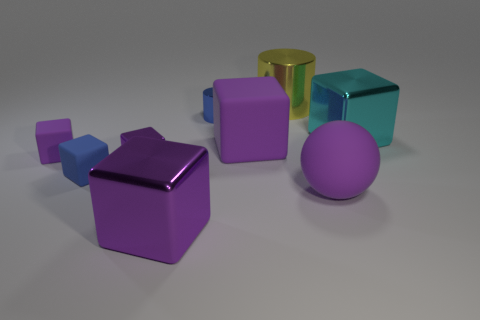There is a matte object that is the same color as the small metallic cylinder; what shape is it?
Your answer should be compact. Cube. What is the shape of the purple metallic thing that is the same size as the blue shiny cylinder?
Give a very brief answer. Cube. What is the material of the cube that is the same color as the small cylinder?
Keep it short and to the point. Rubber. Are there any blue shiny cylinders right of the large yellow thing?
Your answer should be very brief. No. Is there a red metal thing that has the same shape as the large cyan thing?
Provide a succinct answer. No. There is a blue thing that is in front of the big cyan object; is its shape the same as the tiny blue thing right of the small blue block?
Ensure brevity in your answer.  No. Is there a blue rubber cube that has the same size as the blue matte thing?
Provide a short and direct response. No. Are there an equal number of yellow objects right of the small blue rubber thing and large purple matte balls that are behind the blue cylinder?
Your answer should be very brief. No. Do the blue thing that is right of the tiny purple shiny object and the purple block that is behind the tiny purple matte block have the same material?
Keep it short and to the point. No. What is the material of the large cyan cube?
Make the answer very short. Metal. 